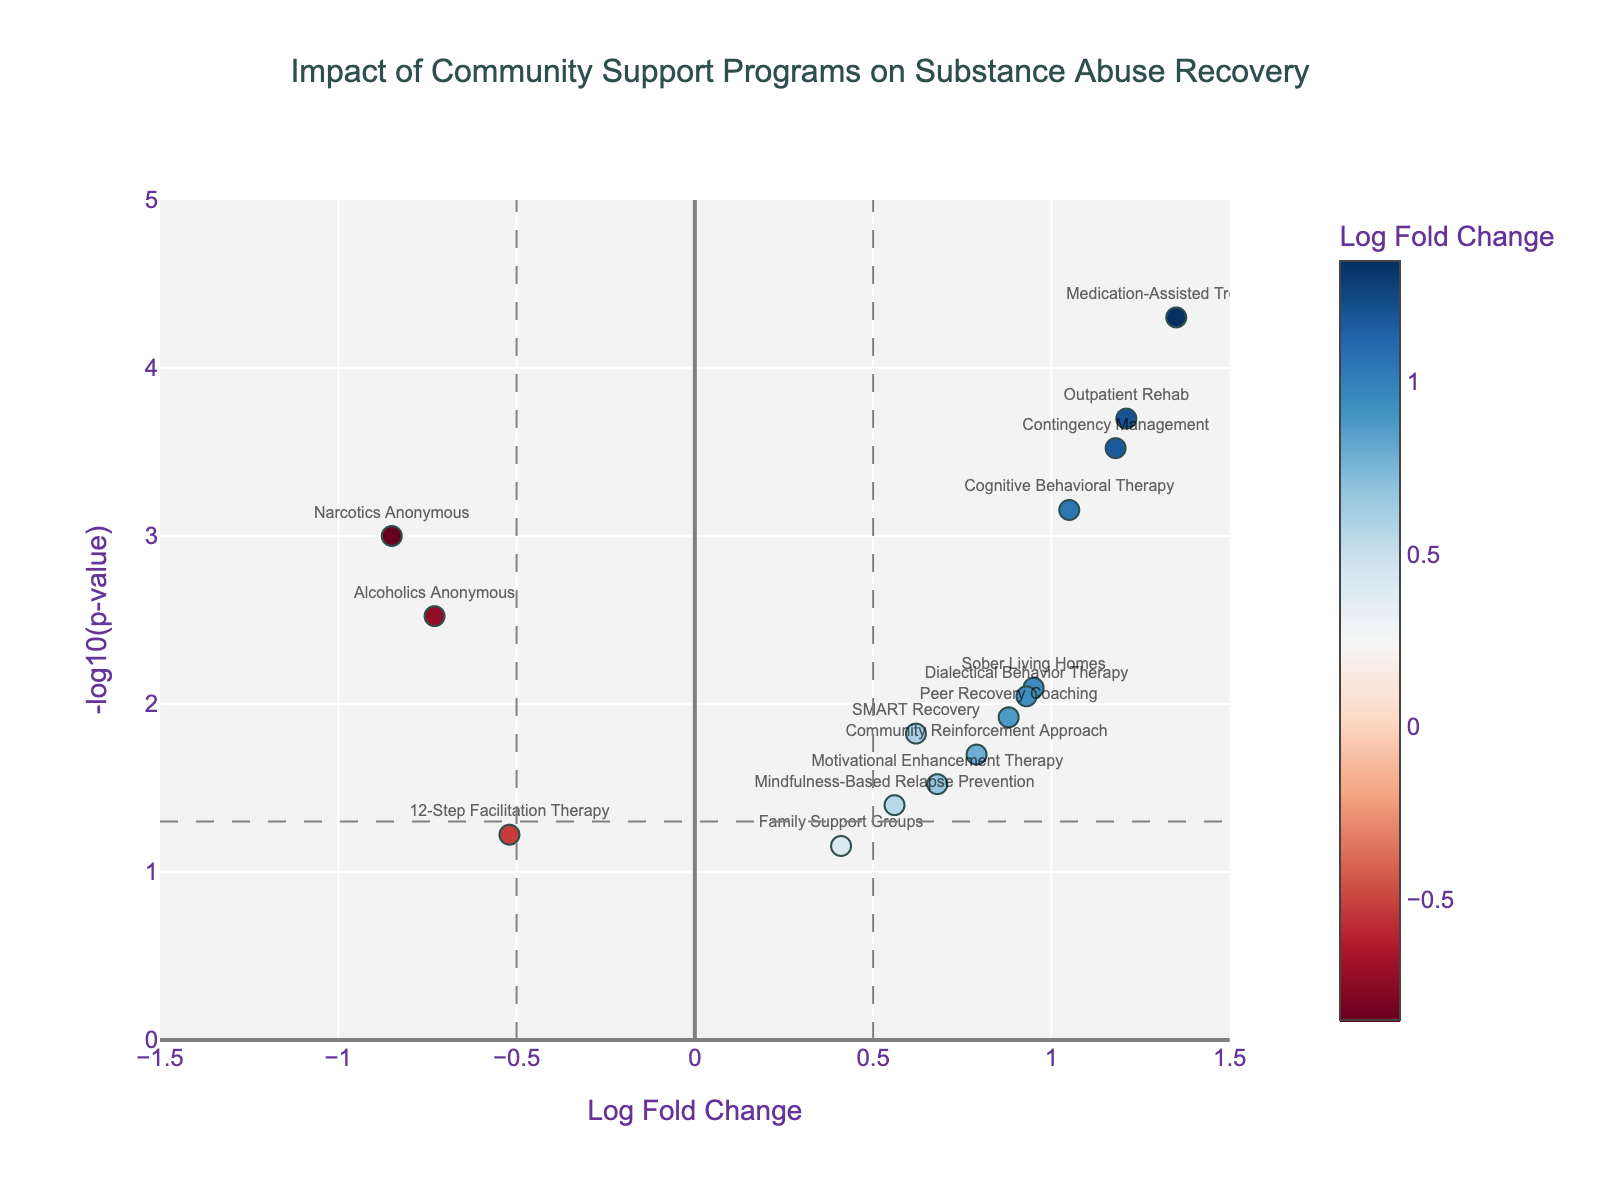How many programs are included in this study? Count each marker on the plot that represents a program. There are 15 markers.
Answer: 15 Which programs demonstrate the highest impact on recovery rates? Identify markers with the highest Log Fold Change values. Medication-Assisted Treatment has the highest Log Fold Change of 1.35, followed by Outpatient Rehab (1.21), and Contingency Management (1.18).
Answer: Medication-Assisted Treatment What is the p-value threshold indicated on the plot? Look for the horizontal line representing the p-value threshold. The line is at y = -log10(0.05) which equals approximately 1.30.
Answer: 0.05 How many programs surpass the significance threshold (p < 0.05)? Count the markers above the horizontal line at y ≈ 1.30. There are 11 markers above this line.
Answer: 11 Which programs have a negative impact on recovery rates? Find markers with negative Log Fold Change values. These are Narcotics Anonymous, Alcoholics Anonymous, and 12-Step Facilitation Therapy.
Answer: Narcotics Anonymous, Alcoholics Anonymous, 12-Step Facilitation Therapy Which program combines high impact and high significance best in terms of recovery? Assess the marker with both high Log Fold Change and high -log10(p-value). Medication-Assisted Treatment has the highest impacts (1.35 log fold change and p-value ≈ 0.00005).
Answer: Medication-Assisted Treatment What is the Log Fold Change value and p-value of Cognitive Behavioral Therapy? Find the corresponding marker and read the hover text for detailed information. Cognitive Behavioral Therapy has a Log Fold Change of 1.05 and a p-value of 0.0007.
Answer: 1.05, 0.0007 Do any programs have a Log Fold Change of approximately 0.5 and a high significance? Look for markers around Log Fold Change ≈ 0.5. Mindfulness-Based Relapse Prevention (Log Fold Change 0.56) and SMART Recovery (Log Fold Change 0.62) have significant p-values (p-values < 0.05).
Answer: SMART Recovery, Mindfulness-Based Relapse Prevention What does the color scale represent in the plot? The marker colors depend on their Log Fold Change values, shown in a colorbar. Colors go from red (negative values) to blue (positive values).
Answer: Log Fold Change values Which program shows a significant result but only a moderate impact on recovery? Identify markers with significant p-values but smaller Log Fold Change. Motivational Enhancement Therapy has a Log Fold Change of 0.68 and a significant p-value around 0.03.
Answer: Motivational Enhancement Therapy 